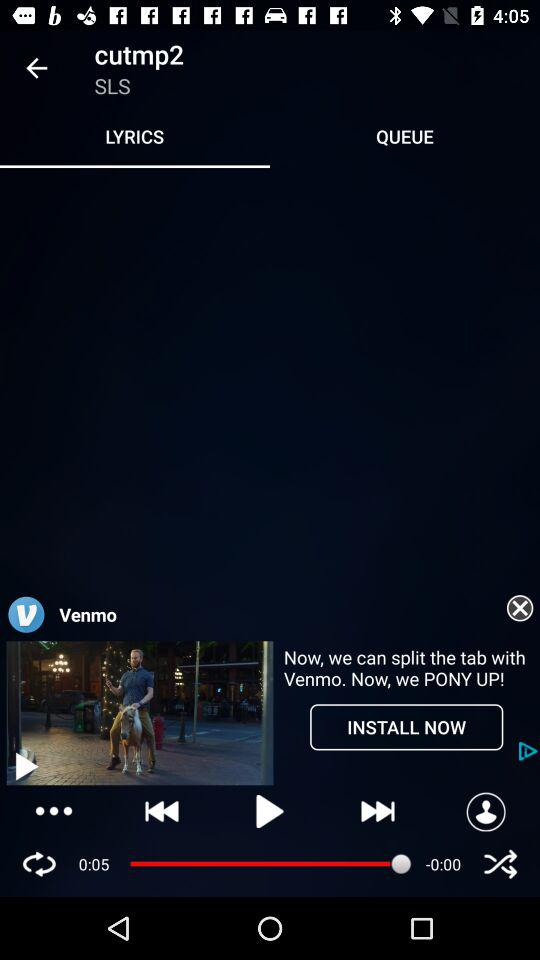What is the application name in the advertisement? The application name in the advertisement is "Venmo". 